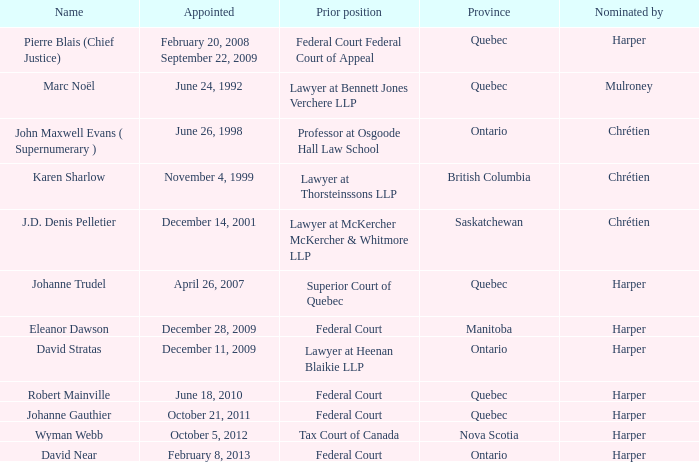What was the prior position held by Wyman Webb? Tax Court of Canada. 